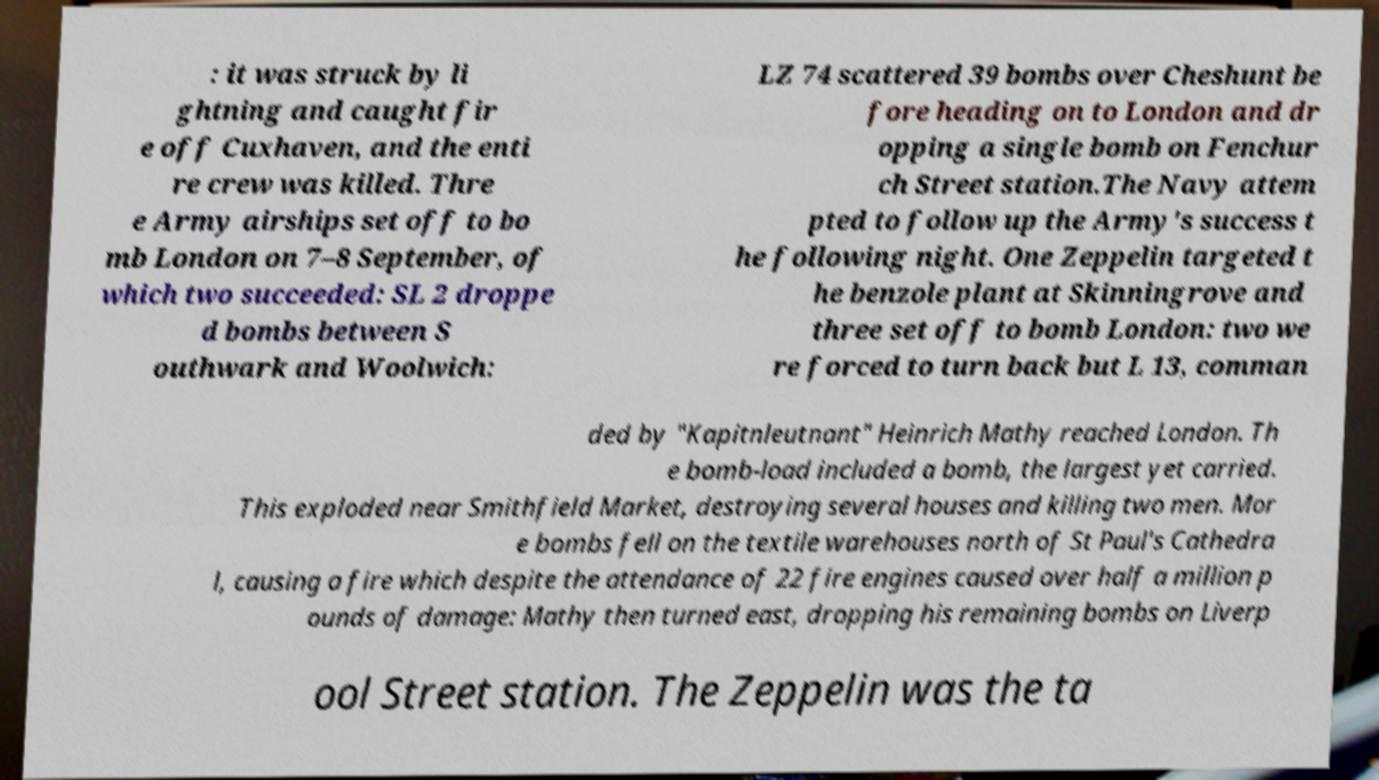Could you extract and type out the text from this image? : it was struck by li ghtning and caught fir e off Cuxhaven, and the enti re crew was killed. Thre e Army airships set off to bo mb London on 7–8 September, of which two succeeded: SL 2 droppe d bombs between S outhwark and Woolwich: LZ 74 scattered 39 bombs over Cheshunt be fore heading on to London and dr opping a single bomb on Fenchur ch Street station.The Navy attem pted to follow up the Army's success t he following night. One Zeppelin targeted t he benzole plant at Skinningrove and three set off to bomb London: two we re forced to turn back but L 13, comman ded by "Kapitnleutnant" Heinrich Mathy reached London. Th e bomb-load included a bomb, the largest yet carried. This exploded near Smithfield Market, destroying several houses and killing two men. Mor e bombs fell on the textile warehouses north of St Paul's Cathedra l, causing a fire which despite the attendance of 22 fire engines caused over half a million p ounds of damage: Mathy then turned east, dropping his remaining bombs on Liverp ool Street station. The Zeppelin was the ta 